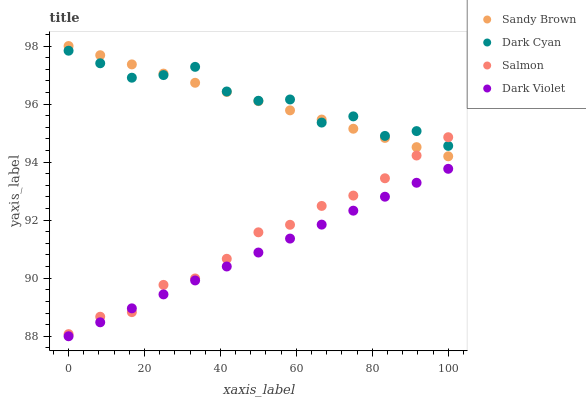Does Dark Violet have the minimum area under the curve?
Answer yes or no. Yes. Does Dark Cyan have the maximum area under the curve?
Answer yes or no. Yes. Does Salmon have the minimum area under the curve?
Answer yes or no. No. Does Salmon have the maximum area under the curve?
Answer yes or no. No. Is Sandy Brown the smoothest?
Answer yes or no. Yes. Is Dark Cyan the roughest?
Answer yes or no. Yes. Is Salmon the smoothest?
Answer yes or no. No. Is Salmon the roughest?
Answer yes or no. No. Does Dark Violet have the lowest value?
Answer yes or no. Yes. Does Salmon have the lowest value?
Answer yes or no. No. Does Sandy Brown have the highest value?
Answer yes or no. Yes. Does Salmon have the highest value?
Answer yes or no. No. Is Dark Violet less than Dark Cyan?
Answer yes or no. Yes. Is Sandy Brown greater than Dark Violet?
Answer yes or no. Yes. Does Salmon intersect Sandy Brown?
Answer yes or no. Yes. Is Salmon less than Sandy Brown?
Answer yes or no. No. Is Salmon greater than Sandy Brown?
Answer yes or no. No. Does Dark Violet intersect Dark Cyan?
Answer yes or no. No. 